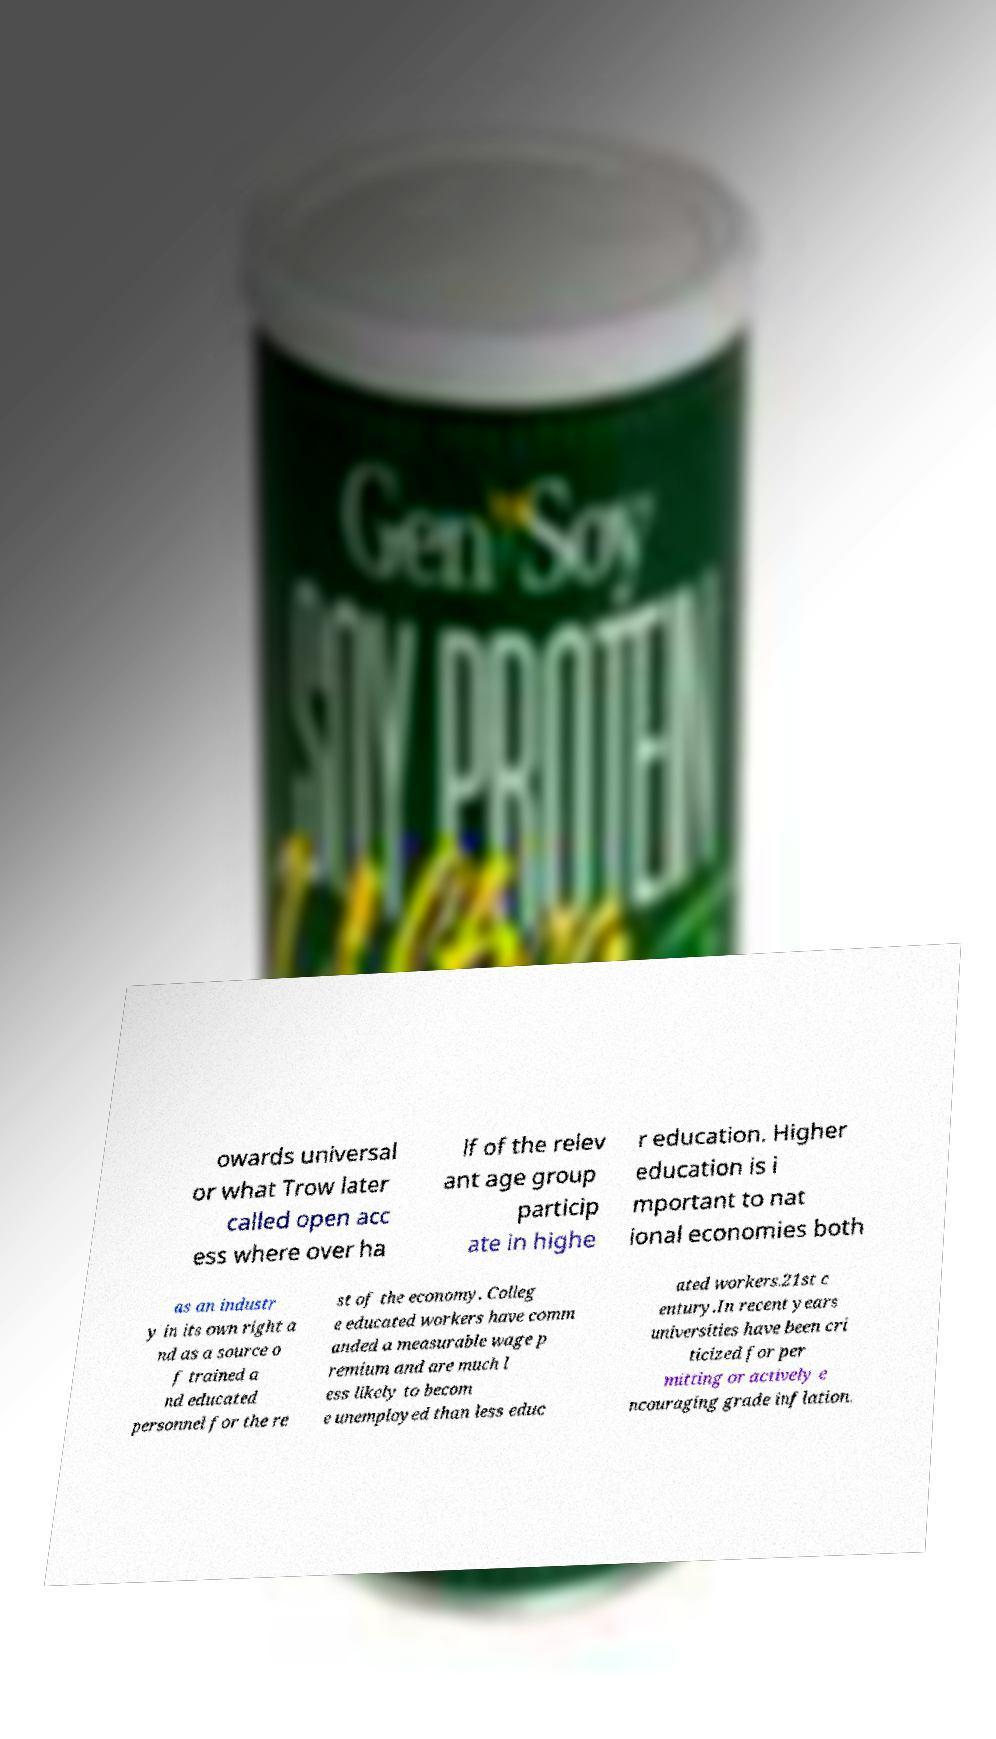Can you read and provide the text displayed in the image?This photo seems to have some interesting text. Can you extract and type it out for me? owards universal or what Trow later called open acc ess where over ha lf of the relev ant age group particip ate in highe r education. Higher education is i mportant to nat ional economies both as an industr y in its own right a nd as a source o f trained a nd educated personnel for the re st of the economy. Colleg e educated workers have comm anded a measurable wage p remium and are much l ess likely to becom e unemployed than less educ ated workers.21st c entury.In recent years universities have been cri ticized for per mitting or actively e ncouraging grade inflation. 